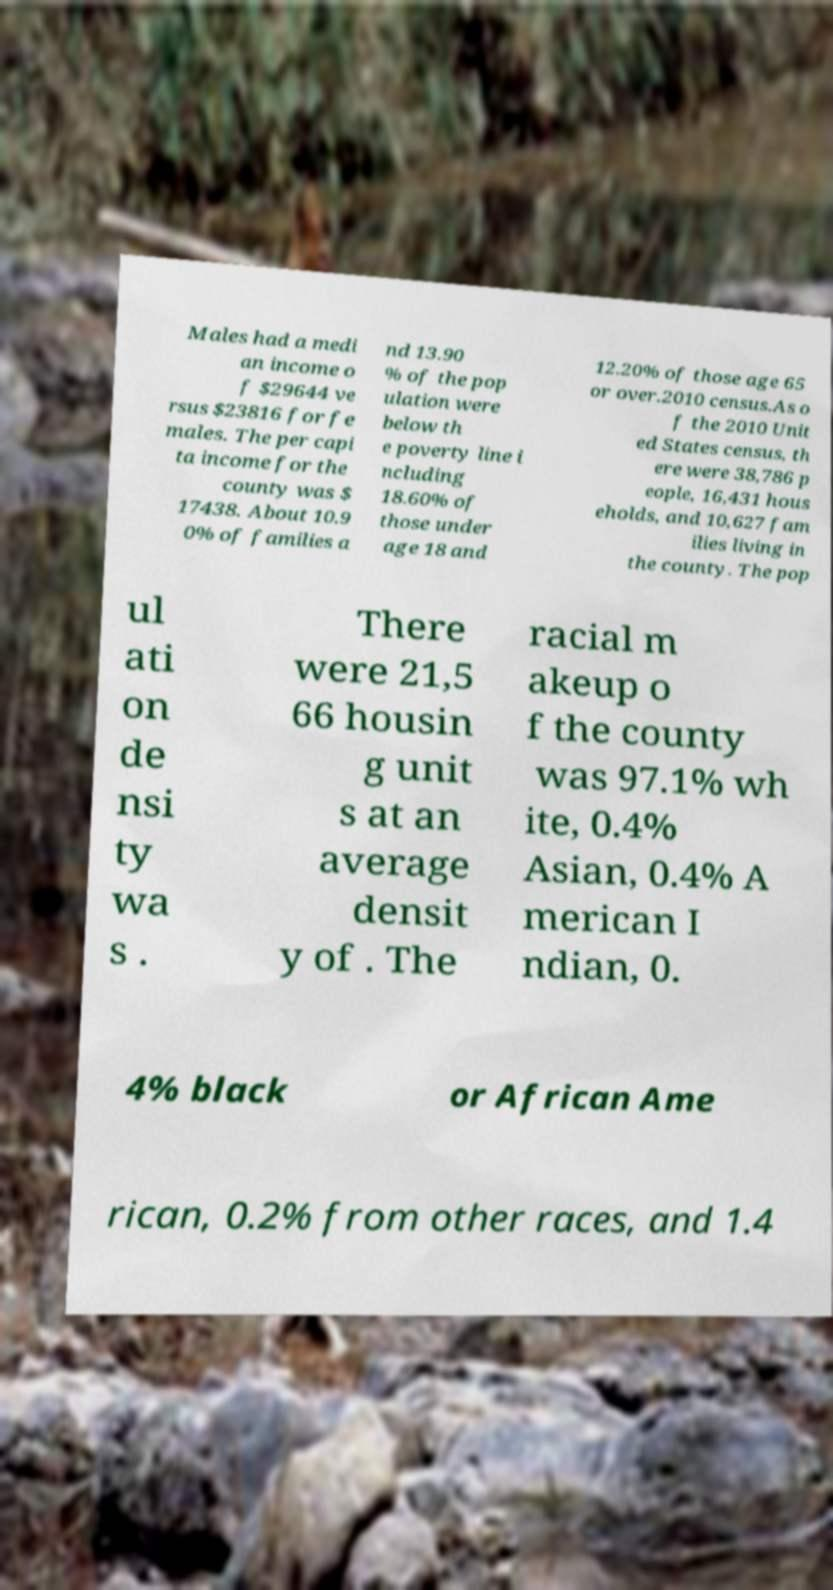Please read and relay the text visible in this image. What does it say? Males had a medi an income o f $29644 ve rsus $23816 for fe males. The per capi ta income for the county was $ 17438. About 10.9 0% of families a nd 13.90 % of the pop ulation were below th e poverty line i ncluding 18.60% of those under age 18 and 12.20% of those age 65 or over.2010 census.As o f the 2010 Unit ed States census, th ere were 38,786 p eople, 16,431 hous eholds, and 10,627 fam ilies living in the county. The pop ul ati on de nsi ty wa s . There were 21,5 66 housin g unit s at an average densit y of . The racial m akeup o f the county was 97.1% wh ite, 0.4% Asian, 0.4% A merican I ndian, 0. 4% black or African Ame rican, 0.2% from other races, and 1.4 